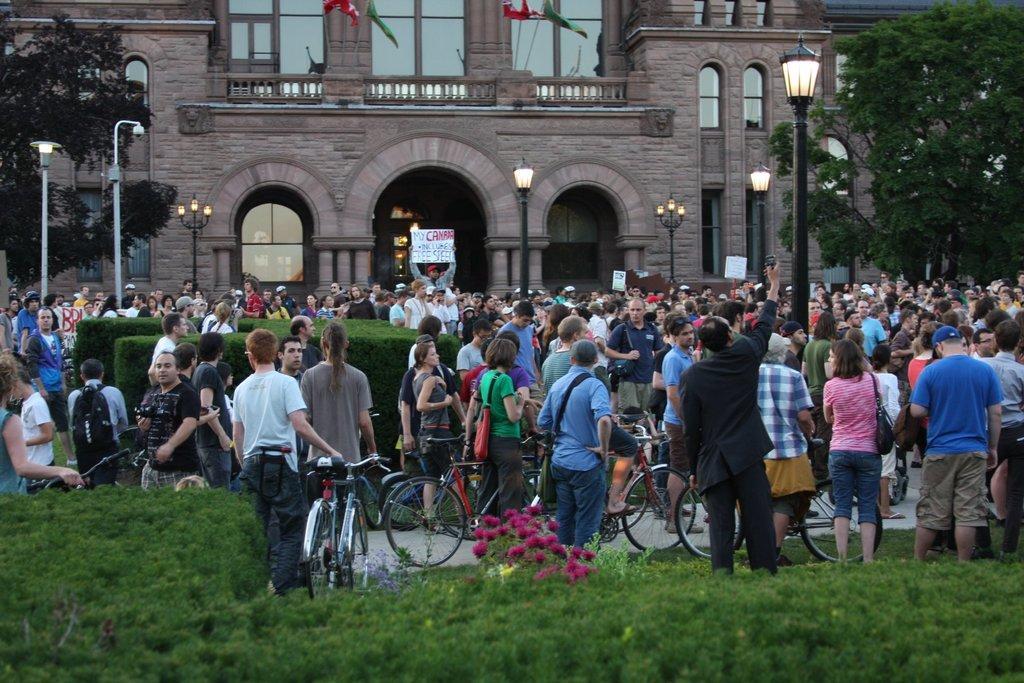Please provide a concise description of this image. In this picture there are group of persons standing where few among them are holding bicycles in their hands and there is a building and a person holding a sheet which has some thing written on it in the background and there are trees and few lights on either sides of them. 